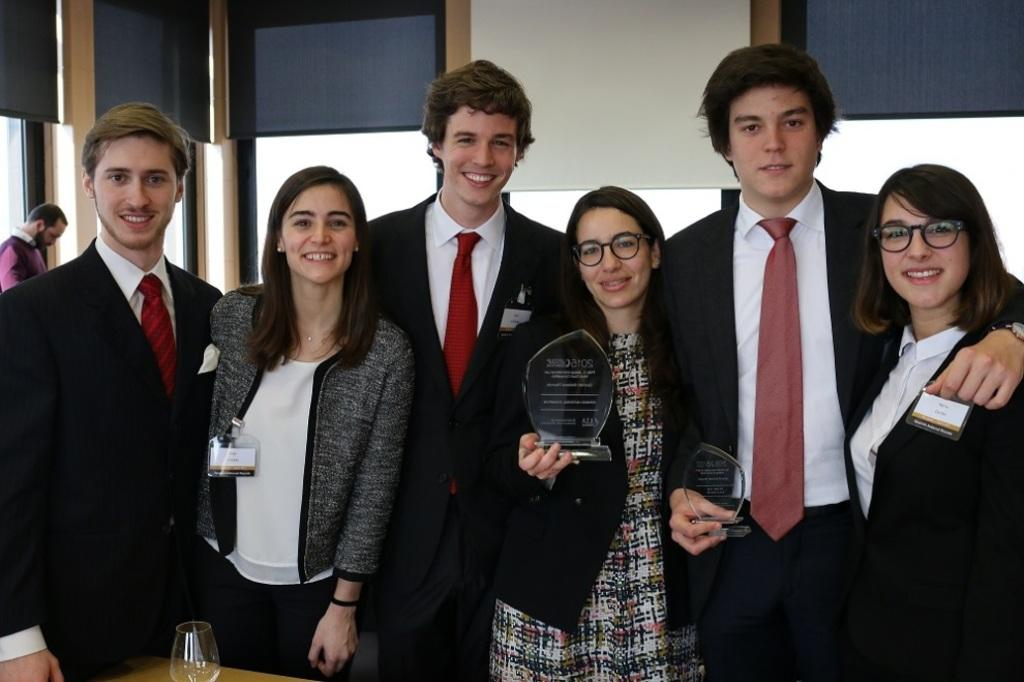What are the persons in the image doing? The persons in the image are standing on the floor and smiling. Can you describe the mood of the persons in the image? The persons in the image appear to be happy, as they are smiling. What object can be seen on a platform in the image? There is a glass on a platform in the image. What rule is being enforced by the persons in the image? There is no indication in the image that the persons are enforcing any rules. Can you describe the stove in the image? There is no stove present in the image. 